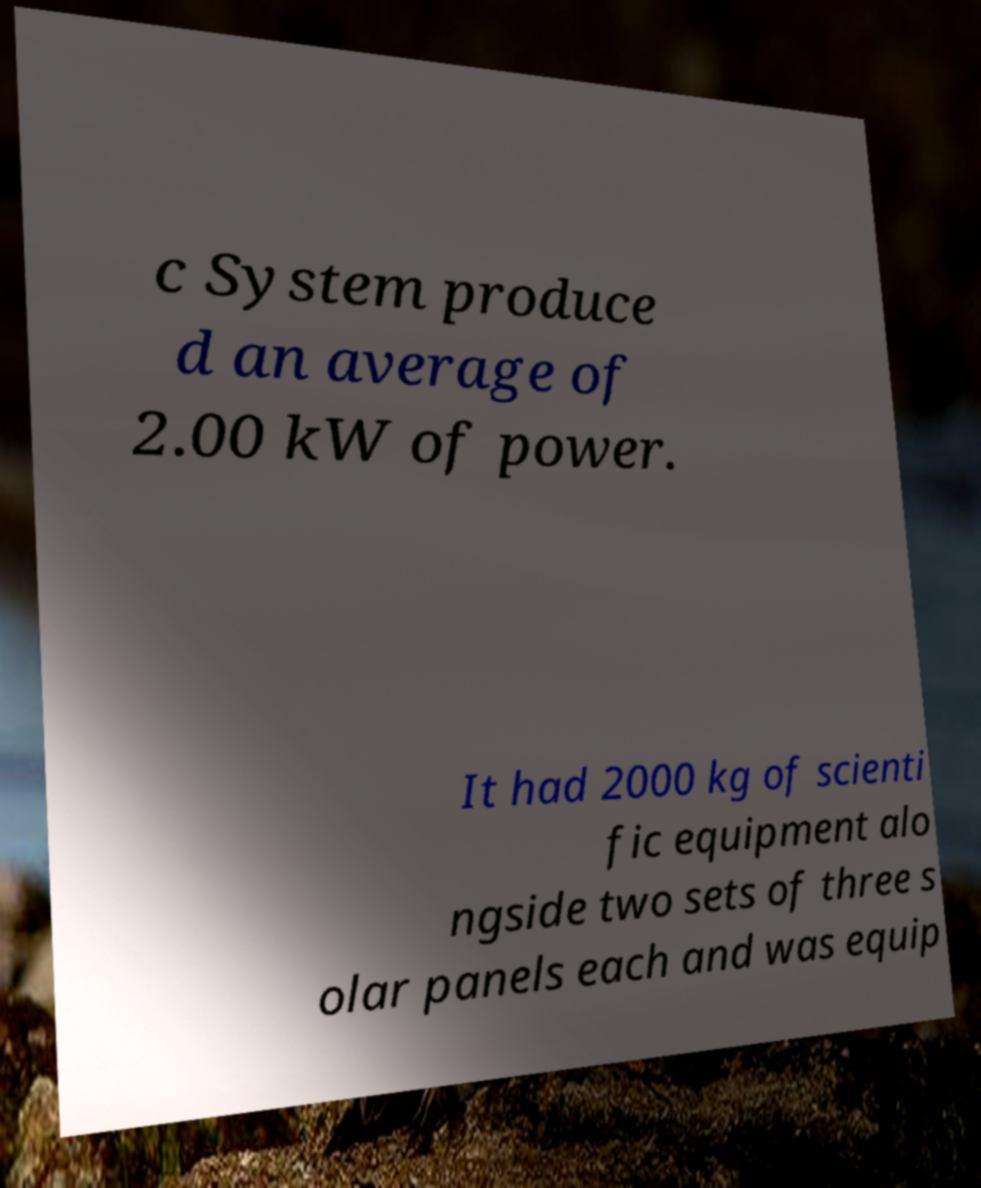For documentation purposes, I need the text within this image transcribed. Could you provide that? c System produce d an average of 2.00 kW of power. It had 2000 kg of scienti fic equipment alo ngside two sets of three s olar panels each and was equip 